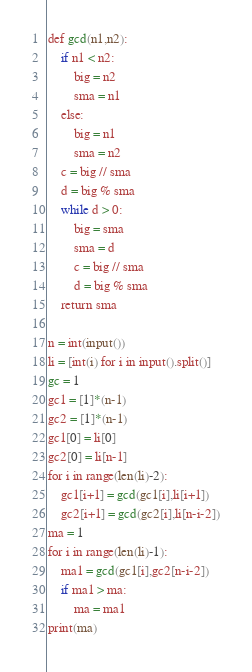Convert code to text. <code><loc_0><loc_0><loc_500><loc_500><_Scheme_>def gcd(n1,n2):
    if n1 < n2:
        big = n2
        sma = n1
    else:
        big = n1
        sma = n2
    c = big // sma
    d = big % sma
    while d > 0:
        big = sma
        sma = d
        c = big // sma
        d = big % sma
    return sma
        
n = int(input())
li = [int(i) for i in input().split()]
gc = 1
gc1 = [1]*(n-1)
gc2 = [1]*(n-1)
gc1[0] = li[0]
gc2[0] = li[n-1]
for i in range(len(li)-2):
    gc1[i+1] = gcd(gc1[i],li[i+1])
    gc2[i+1] = gcd(gc2[i],li[n-i-2])
ma = 1
for i in range(len(li)-1):
    ma1 = gcd(gc1[i],gc2[n-i-2])
    if ma1 > ma:
        ma = ma1
print(ma)</code> 